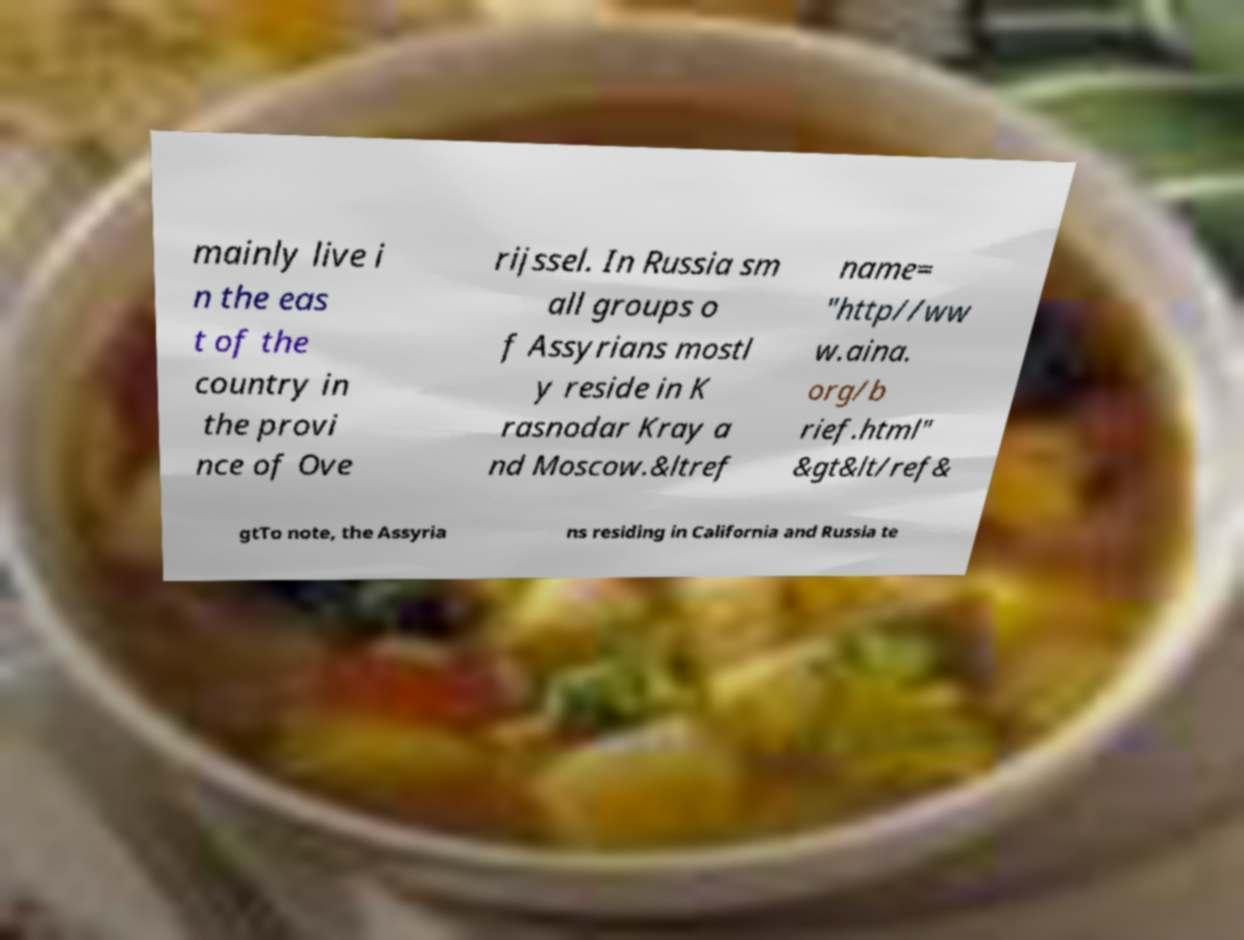Please read and relay the text visible in this image. What does it say? mainly live i n the eas t of the country in the provi nce of Ove rijssel. In Russia sm all groups o f Assyrians mostl y reside in K rasnodar Kray a nd Moscow.&ltref name= "http//ww w.aina. org/b rief.html" &gt&lt/ref& gtTo note, the Assyria ns residing in California and Russia te 